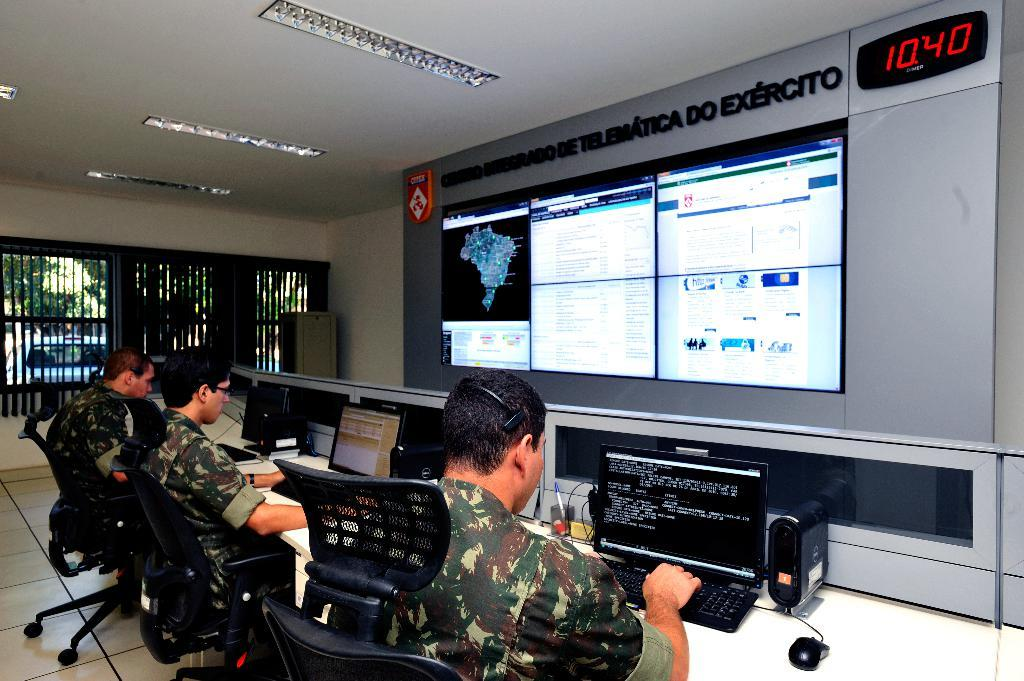Provide a one-sentence caption for the provided image. people in military uniform in front of monitors and sign reading Exercito. 